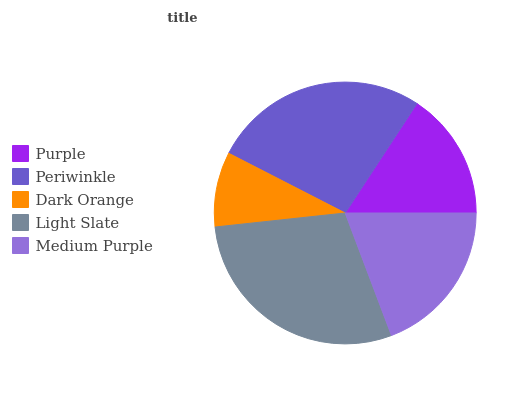Is Dark Orange the minimum?
Answer yes or no. Yes. Is Light Slate the maximum?
Answer yes or no. Yes. Is Periwinkle the minimum?
Answer yes or no. No. Is Periwinkle the maximum?
Answer yes or no. No. Is Periwinkle greater than Purple?
Answer yes or no. Yes. Is Purple less than Periwinkle?
Answer yes or no. Yes. Is Purple greater than Periwinkle?
Answer yes or no. No. Is Periwinkle less than Purple?
Answer yes or no. No. Is Medium Purple the high median?
Answer yes or no. Yes. Is Medium Purple the low median?
Answer yes or no. Yes. Is Purple the high median?
Answer yes or no. No. Is Dark Orange the low median?
Answer yes or no. No. 